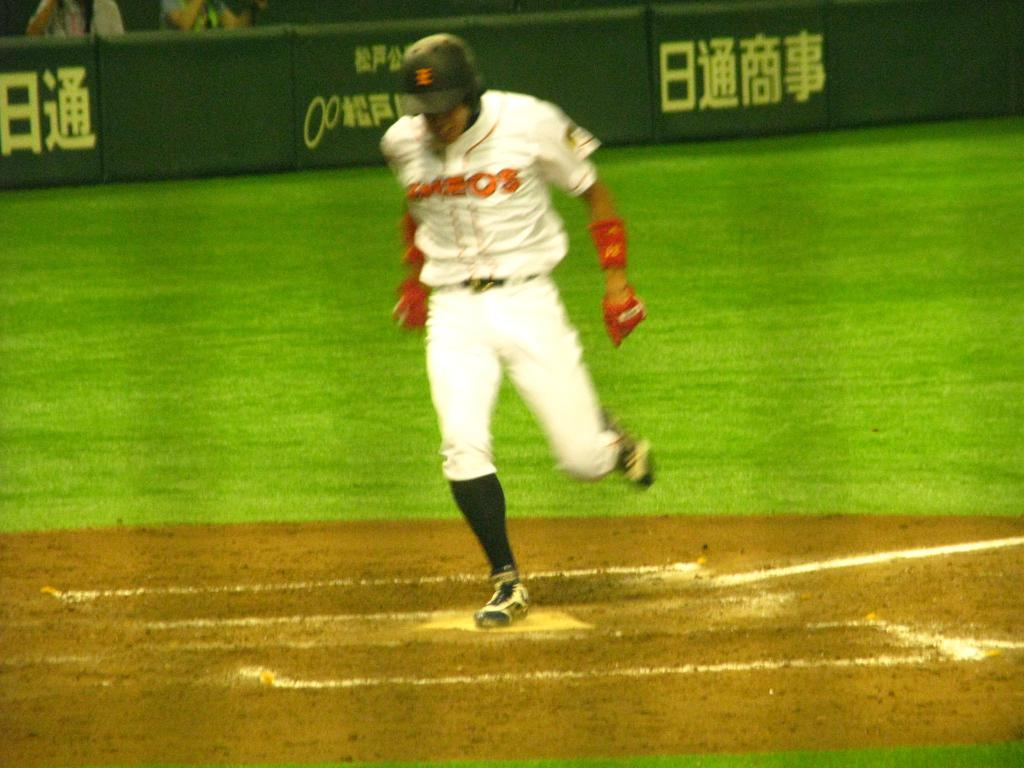<image>
Describe the image concisely. a player running with Japanese writing on the wall behind him 